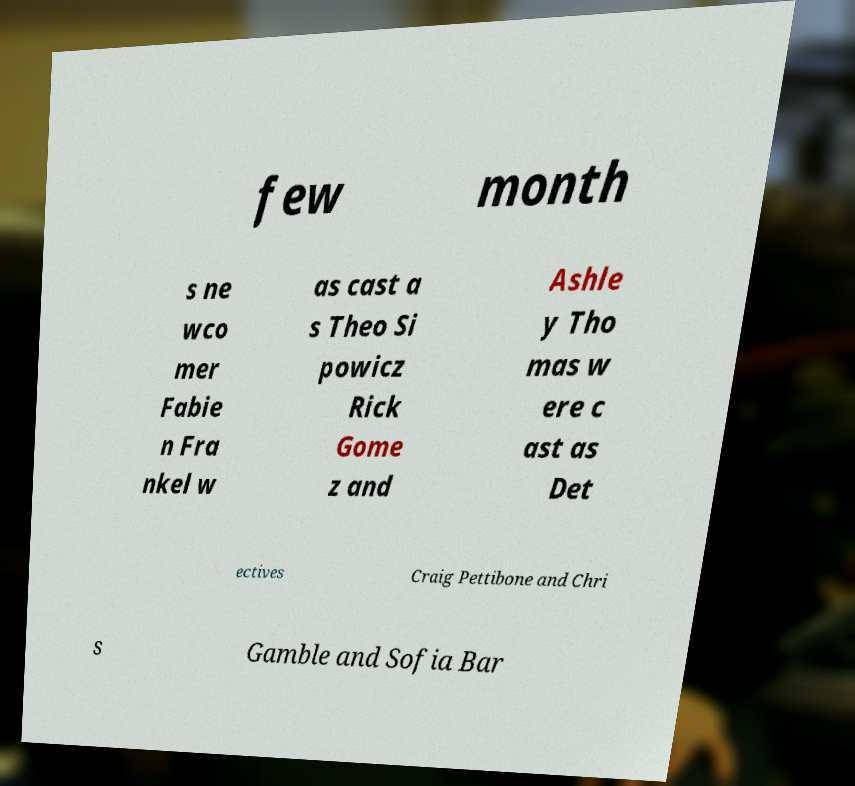Please read and relay the text visible in this image. What does it say? few month s ne wco mer Fabie n Fra nkel w as cast a s Theo Si powicz Rick Gome z and Ashle y Tho mas w ere c ast as Det ectives Craig Pettibone and Chri s Gamble and Sofia Bar 